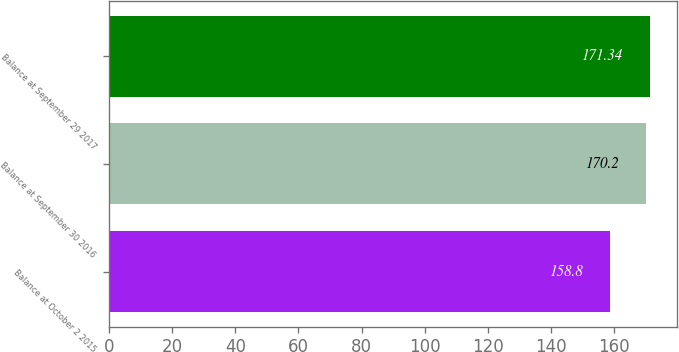Convert chart to OTSL. <chart><loc_0><loc_0><loc_500><loc_500><bar_chart><fcel>Balance at October 2 2015<fcel>Balance at September 30 2016<fcel>Balance at September 29 2017<nl><fcel>158.8<fcel>170.2<fcel>171.34<nl></chart> 